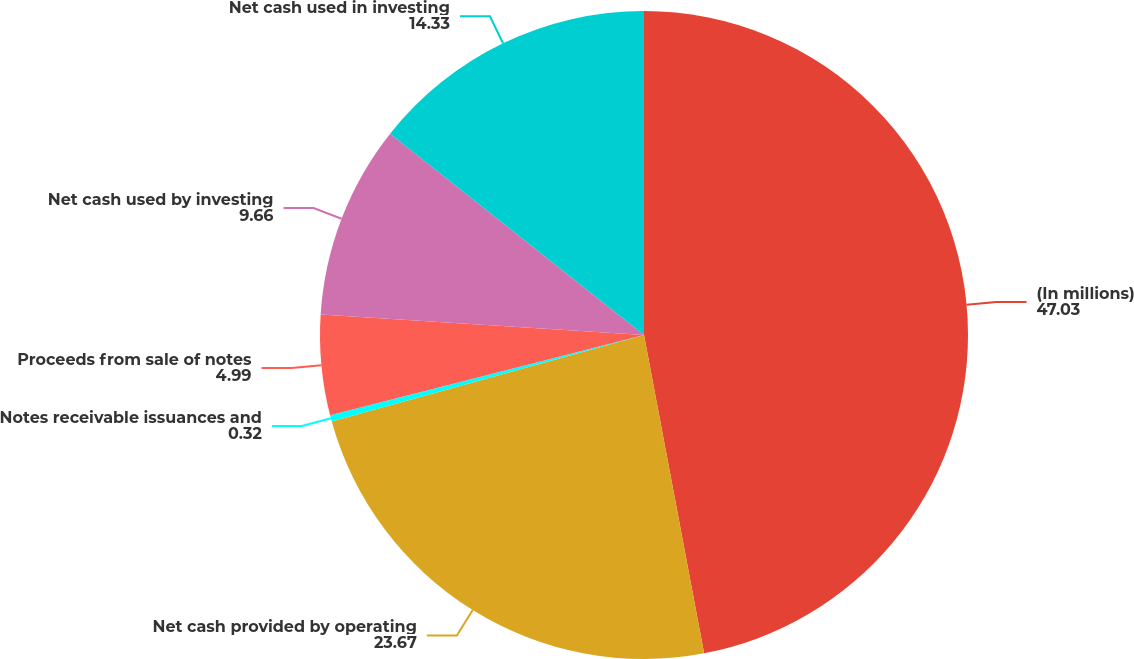<chart> <loc_0><loc_0><loc_500><loc_500><pie_chart><fcel>(In millions)<fcel>Net cash provided by operating<fcel>Notes receivable issuances and<fcel>Proceeds from sale of notes<fcel>Net cash used by investing<fcel>Net cash used in investing<nl><fcel>47.03%<fcel>23.67%<fcel>0.32%<fcel>4.99%<fcel>9.66%<fcel>14.33%<nl></chart> 